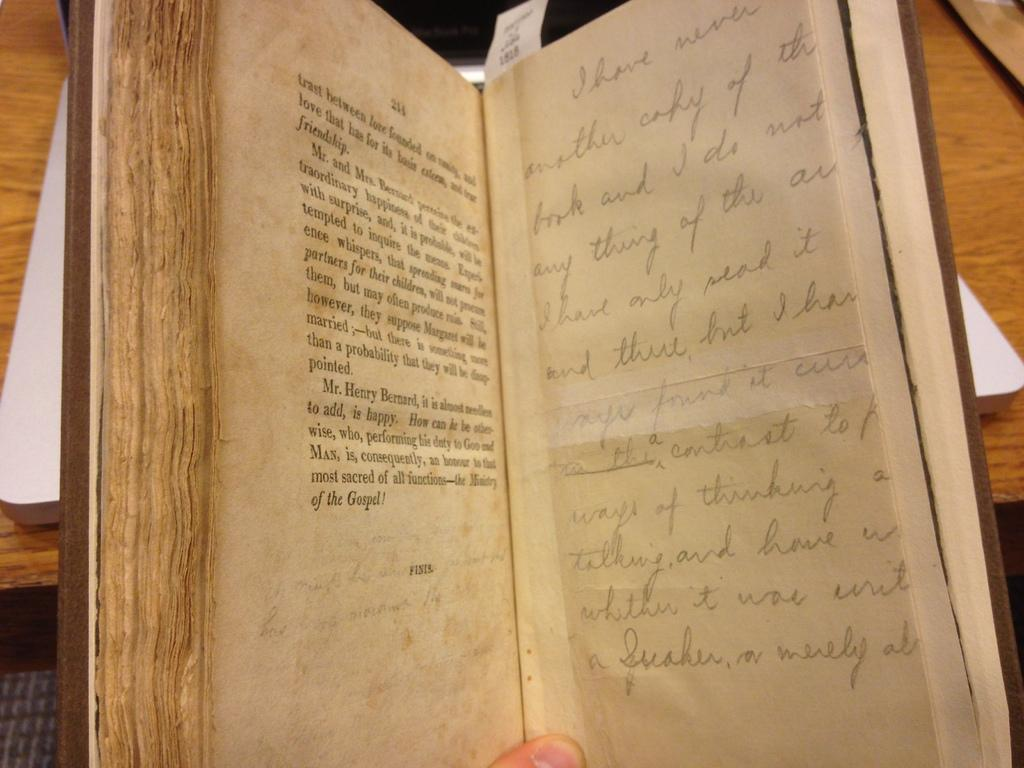<image>
Write a terse but informative summary of the picture. A book with print and handwriting is opened to page 214. 